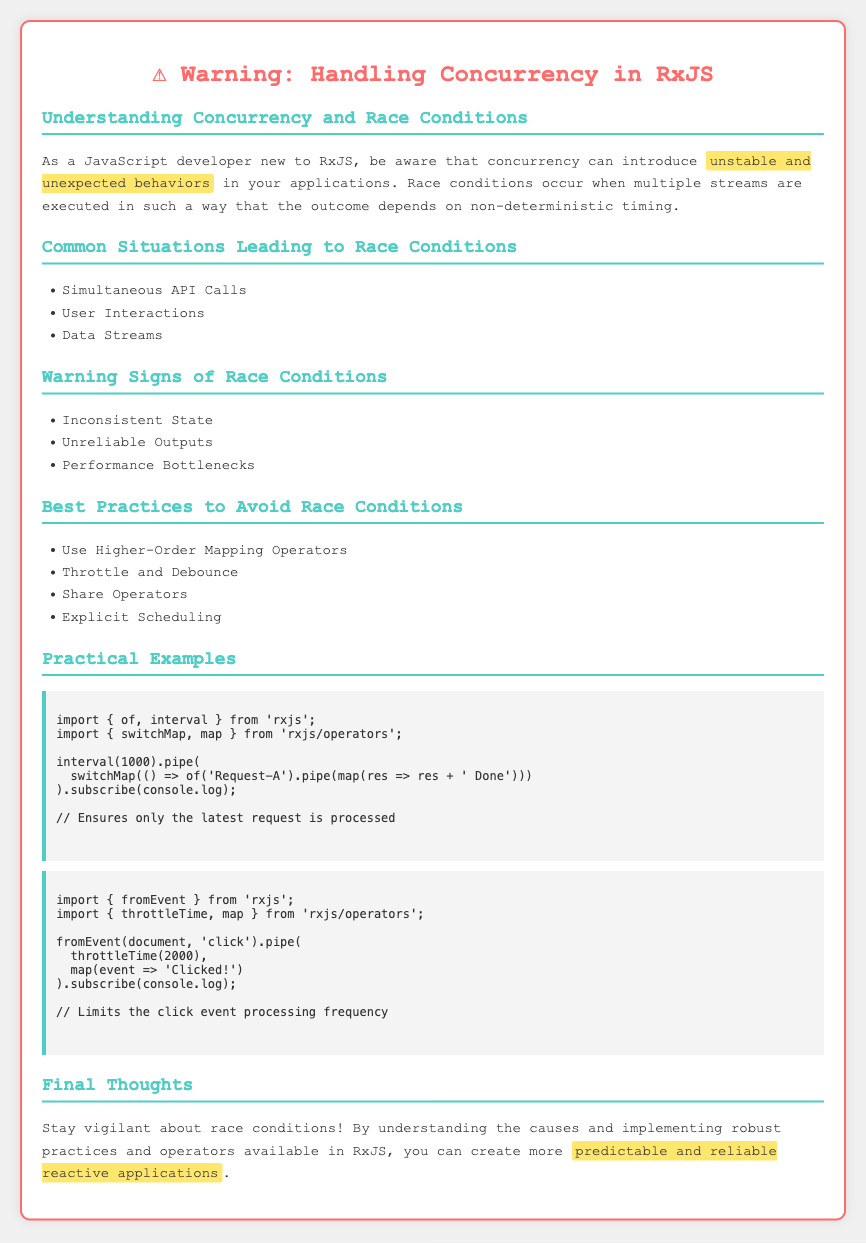What is the title of the document? The title is indicated in the head section of the HTML document.
Answer: RxJS Concurrency Warning What are the common situations that lead to race conditions? The document lists these situations in a bullet point format.
Answer: Simultaneous API Calls, User Interactions, Data Streams What is a warning sign of race conditions? The document lists warning signs in a bullet point format.
Answer: Inconsistent State What is one best practice to avoid race conditions? The document outlines best practices in a separate section.
Answer: Use Higher-Order Mapping Operators What operator is used to ensure only the latest request is processed? The document provides a code example where this operator is utilized.
Answer: switchMap What type of events does the second code example handle? The document describes the context in which the second example operates.
Answer: click events What is the time limit set for throttling in the second example? The document specifies this in the second code example section.
Answer: 2000 milliseconds What color is used for the warning title? The styling information in the document indicates the title color.
Answer: #ff6b6b What should you stay vigilant about according to the final thoughts? The final thoughts section contains key warnings.
Answer: race conditions 